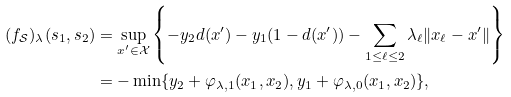Convert formula to latex. <formula><loc_0><loc_0><loc_500><loc_500>( f _ { \mathcal { S } } ) _ { \lambda } ( s _ { 1 } , s _ { 2 } ) & = \sup _ { x ^ { \prime } \in \mathcal { X } } \left \{ - y _ { 2 } d ( x ^ { \prime } ) - y _ { 1 } ( 1 - d ( x ^ { \prime } ) ) - \sum _ { 1 \leq \ell \leq 2 } \lambda _ { \ell } \| x _ { \ell } - x ^ { \prime } \| \right \} \\ & = - \min \{ y _ { 2 } + \varphi _ { \lambda , 1 } ( x _ { 1 } , x _ { 2 } ) , y _ { 1 } + \varphi _ { \lambda , 0 } ( x _ { 1 } , x _ { 2 } ) \} ,</formula> 